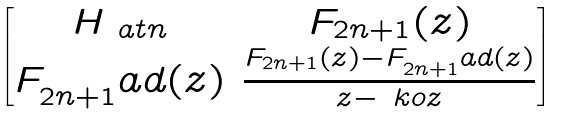Convert formula to latex. <formula><loc_0><loc_0><loc_500><loc_500>\begin{bmatrix} H _ { \ a t n } & F _ { 2 n + 1 } ( z ) \\ F _ { 2 n + 1 } ^ { \ } a d ( z ) & \frac { F _ { 2 n + 1 } ( z ) - F _ { 2 n + 1 } ^ { \ } a d ( z ) } { z - \ k o z } \end{bmatrix}</formula> 